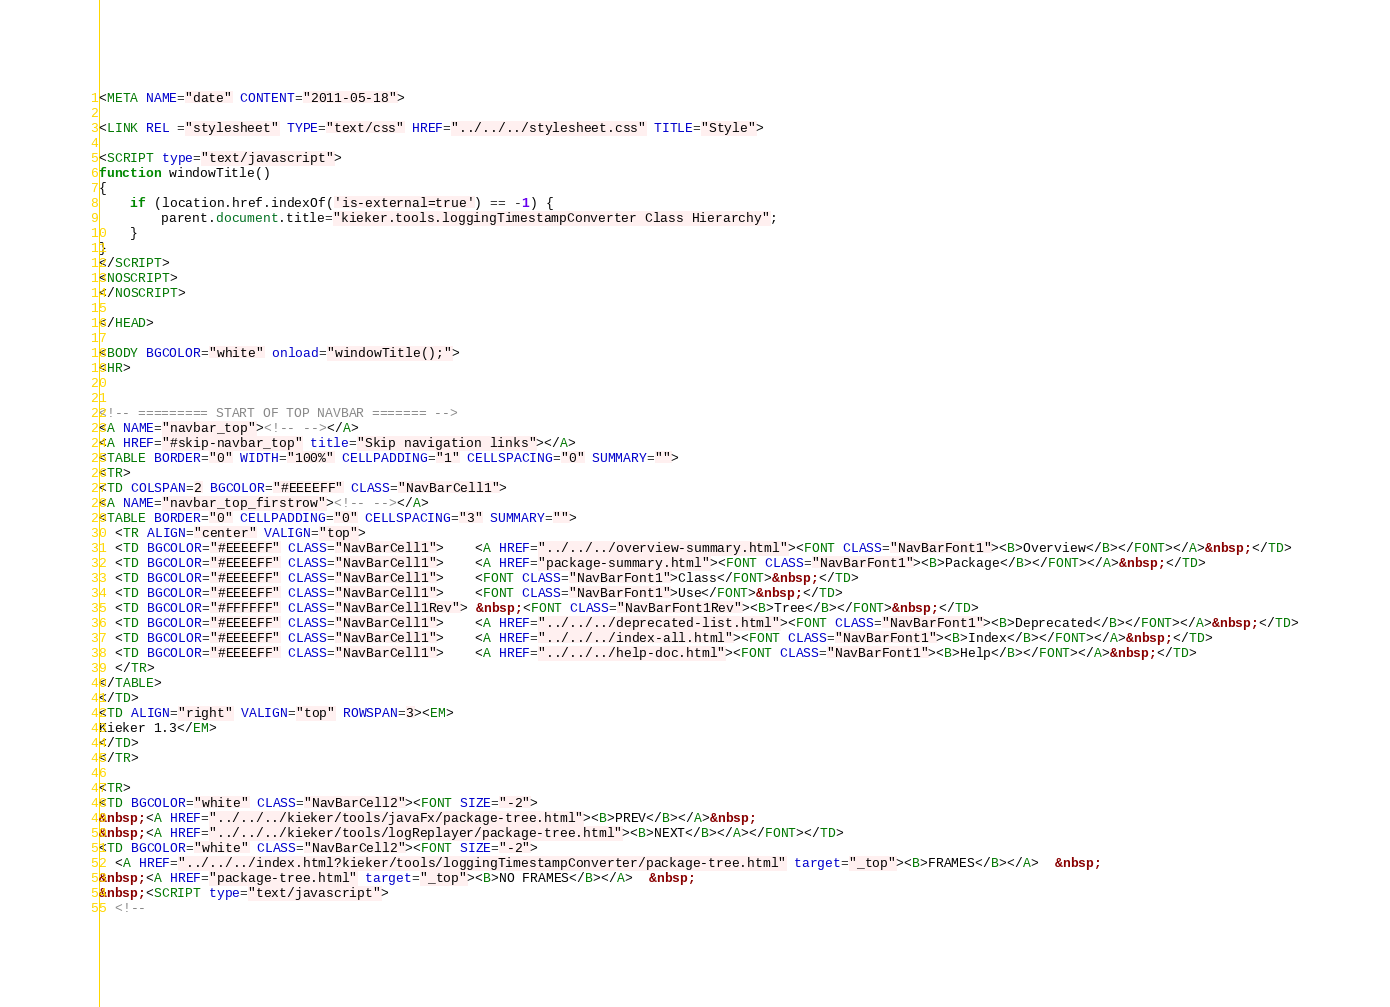<code> <loc_0><loc_0><loc_500><loc_500><_HTML_><META NAME="date" CONTENT="2011-05-18">

<LINK REL ="stylesheet" TYPE="text/css" HREF="../../../stylesheet.css" TITLE="Style">

<SCRIPT type="text/javascript">
function windowTitle()
{
    if (location.href.indexOf('is-external=true') == -1) {
        parent.document.title="kieker.tools.loggingTimestampConverter Class Hierarchy";
    }
}
</SCRIPT>
<NOSCRIPT>
</NOSCRIPT>

</HEAD>

<BODY BGCOLOR="white" onload="windowTitle();">
<HR>


<!-- ========= START OF TOP NAVBAR ======= -->
<A NAME="navbar_top"><!-- --></A>
<A HREF="#skip-navbar_top" title="Skip navigation links"></A>
<TABLE BORDER="0" WIDTH="100%" CELLPADDING="1" CELLSPACING="0" SUMMARY="">
<TR>
<TD COLSPAN=2 BGCOLOR="#EEEEFF" CLASS="NavBarCell1">
<A NAME="navbar_top_firstrow"><!-- --></A>
<TABLE BORDER="0" CELLPADDING="0" CELLSPACING="3" SUMMARY="">
  <TR ALIGN="center" VALIGN="top">
  <TD BGCOLOR="#EEEEFF" CLASS="NavBarCell1">    <A HREF="../../../overview-summary.html"><FONT CLASS="NavBarFont1"><B>Overview</B></FONT></A>&nbsp;</TD>
  <TD BGCOLOR="#EEEEFF" CLASS="NavBarCell1">    <A HREF="package-summary.html"><FONT CLASS="NavBarFont1"><B>Package</B></FONT></A>&nbsp;</TD>
  <TD BGCOLOR="#EEEEFF" CLASS="NavBarCell1">    <FONT CLASS="NavBarFont1">Class</FONT>&nbsp;</TD>
  <TD BGCOLOR="#EEEEFF" CLASS="NavBarCell1">    <FONT CLASS="NavBarFont1">Use</FONT>&nbsp;</TD>
  <TD BGCOLOR="#FFFFFF" CLASS="NavBarCell1Rev"> &nbsp;<FONT CLASS="NavBarFont1Rev"><B>Tree</B></FONT>&nbsp;</TD>
  <TD BGCOLOR="#EEEEFF" CLASS="NavBarCell1">    <A HREF="../../../deprecated-list.html"><FONT CLASS="NavBarFont1"><B>Deprecated</B></FONT></A>&nbsp;</TD>
  <TD BGCOLOR="#EEEEFF" CLASS="NavBarCell1">    <A HREF="../../../index-all.html"><FONT CLASS="NavBarFont1"><B>Index</B></FONT></A>&nbsp;</TD>
  <TD BGCOLOR="#EEEEFF" CLASS="NavBarCell1">    <A HREF="../../../help-doc.html"><FONT CLASS="NavBarFont1"><B>Help</B></FONT></A>&nbsp;</TD>
  </TR>
</TABLE>
</TD>
<TD ALIGN="right" VALIGN="top" ROWSPAN=3><EM>
Kieker 1.3</EM>
</TD>
</TR>

<TR>
<TD BGCOLOR="white" CLASS="NavBarCell2"><FONT SIZE="-2">
&nbsp;<A HREF="../../../kieker/tools/javaFx/package-tree.html"><B>PREV</B></A>&nbsp;
&nbsp;<A HREF="../../../kieker/tools/logReplayer/package-tree.html"><B>NEXT</B></A></FONT></TD>
<TD BGCOLOR="white" CLASS="NavBarCell2"><FONT SIZE="-2">
  <A HREF="../../../index.html?kieker/tools/loggingTimestampConverter/package-tree.html" target="_top"><B>FRAMES</B></A>  &nbsp;
&nbsp;<A HREF="package-tree.html" target="_top"><B>NO FRAMES</B></A>  &nbsp;
&nbsp;<SCRIPT type="text/javascript">
  <!--</code> 